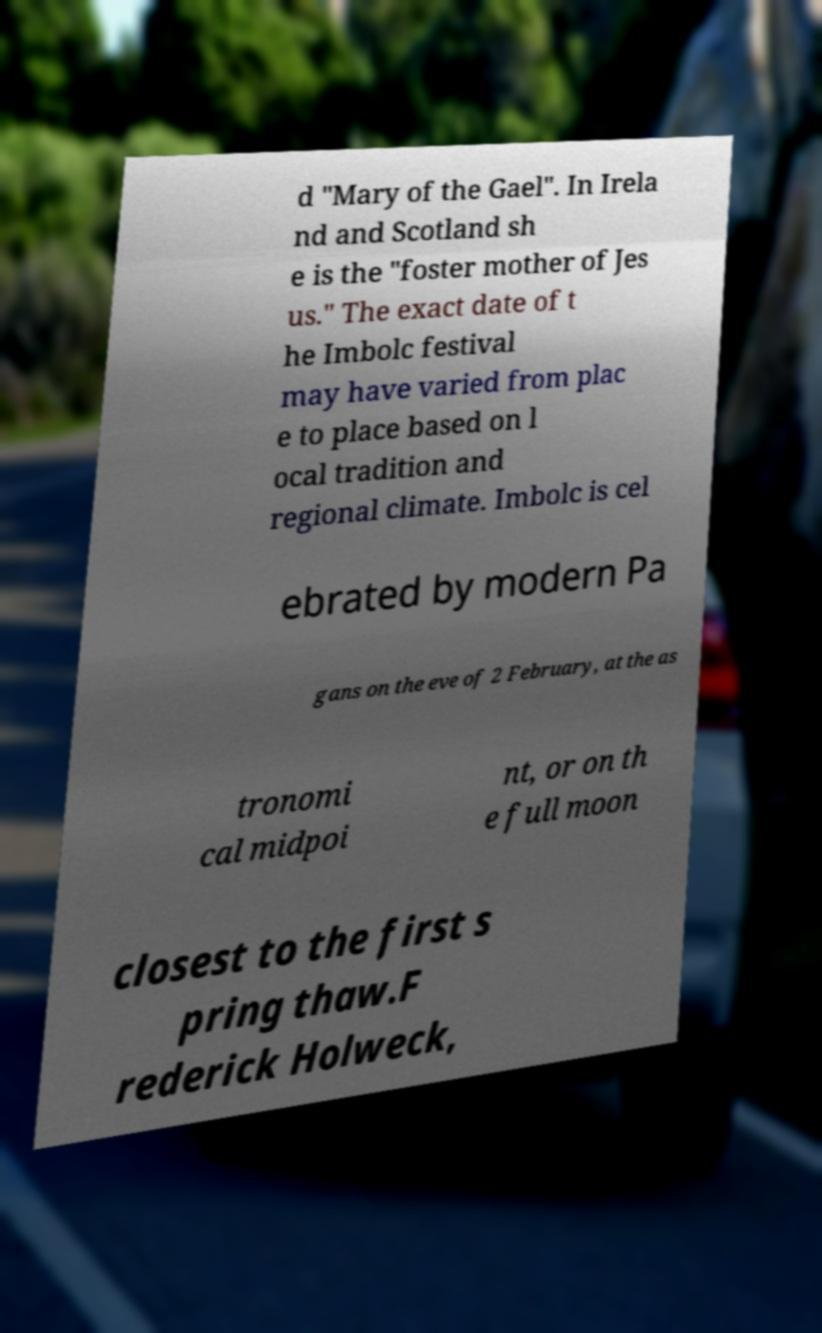Please identify and transcribe the text found in this image. d "Mary of the Gael". In Irela nd and Scotland sh e is the "foster mother of Jes us." The exact date of t he Imbolc festival may have varied from plac e to place based on l ocal tradition and regional climate. Imbolc is cel ebrated by modern Pa gans on the eve of 2 February, at the as tronomi cal midpoi nt, or on th e full moon closest to the first s pring thaw.F rederick Holweck, 